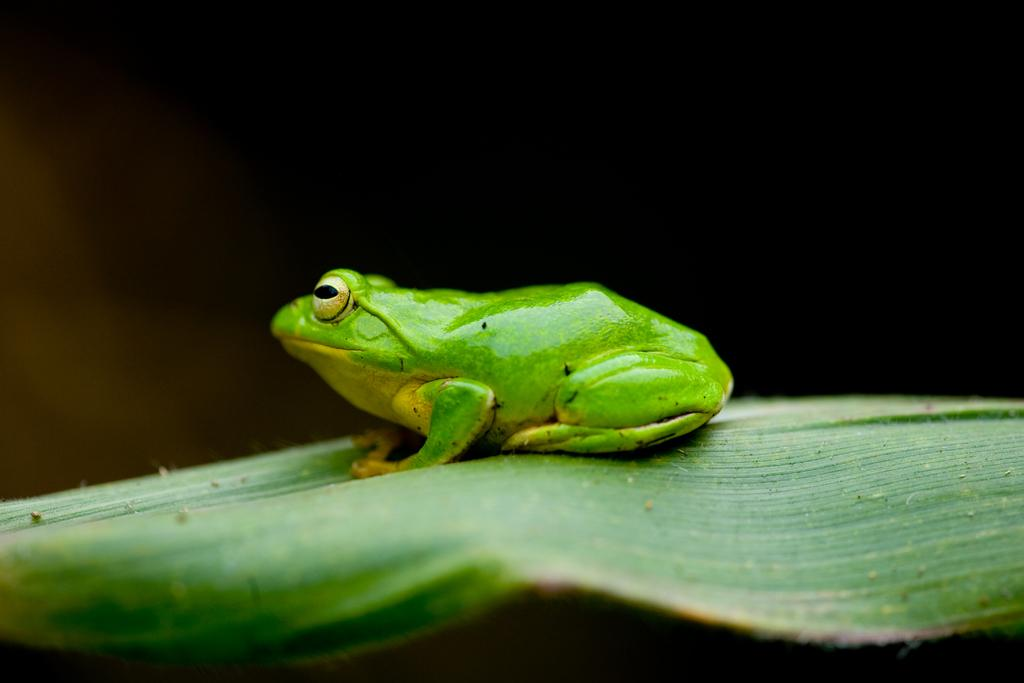What is the main subject of the image? There is a frog in the image. Where is the frog located? The frog is on a leaf. What color is the frog? The frog is green in color. How would you describe the background of the image? The background of the image is dark. What does the caption say about the dog in the image? There is no dog or caption present in the image; it features a green frog on a leaf with a dark background. 